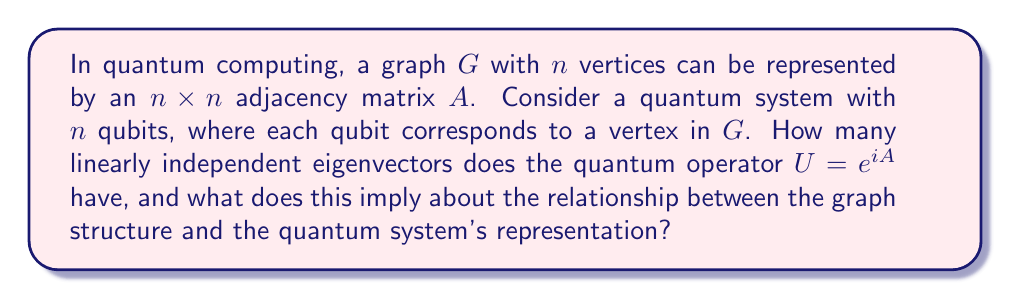Show me your answer to this math problem. Let's approach this step-by-step:

1) First, recall that for any Hermitian matrix $M$, $e^{iM}$ is unitary.

2) The adjacency matrix $A$ of an undirected graph is always symmetric, and thus Hermitian.

3) Therefore, $U = e^{iA}$ is a unitary operator.

4) A key property of unitary operators is that they are always diagonalizable and have a complete set of orthonormal eigenvectors.

5) For an $n \times n$ matrix, a complete set of eigenvectors consists of $n$ linearly independent vectors.

6) This means that $U = e^{iA}$ will always have exactly $n$ linearly independent eigenvectors, regardless of the structure of the original graph $G$.

7) The implication of this result is profound:
   - Every graph, no matter its structure, when transformed into a quantum operator via $U = e^{iA}$, results in a system with a complete basis of eigenstates.
   - This means that the quantum representation $U$ captures all possible states of the system, providing a full representation of the graph in the quantum domain.

8) Moreover, while the graph structure determines the specific eigenvectors and eigenvalues, the dimensionality of the eigenspace is invariant.

9) This illustrates a fundamental connection between graph theory and representation theory in quantum computing: the graph structure is encoded in the eigenvectors and eigenvalues of $U$, while the representation theory guarantees a complete basis regardless of the graph's complexity.
Answer: $n$ linearly independent eigenvectors; complete quantum representation of graph structure. 